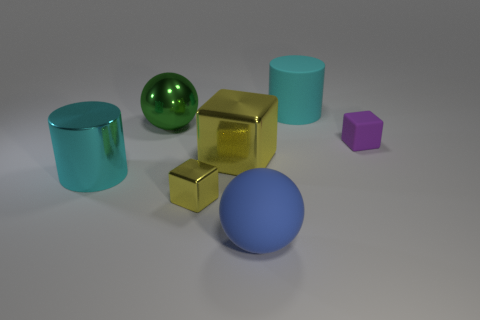Subtract all yellow balls. Subtract all red blocks. How many balls are left? 2 Add 1 small purple matte objects. How many objects exist? 8 Subtract all balls. How many objects are left? 5 Add 5 cyan cylinders. How many cyan cylinders exist? 7 Subtract 0 gray cubes. How many objects are left? 7 Subtract all purple rubber things. Subtract all yellow things. How many objects are left? 4 Add 5 tiny yellow blocks. How many tiny yellow blocks are left? 6 